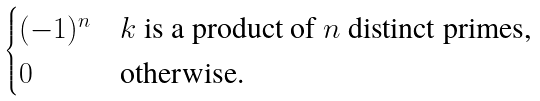Convert formula to latex. <formula><loc_0><loc_0><loc_500><loc_500>\begin{cases} ( - 1 ) ^ { n } & \text {$k$ is a product of $n$ distinct primes,} \\ 0 & \text {otherwise.} \end{cases}</formula> 